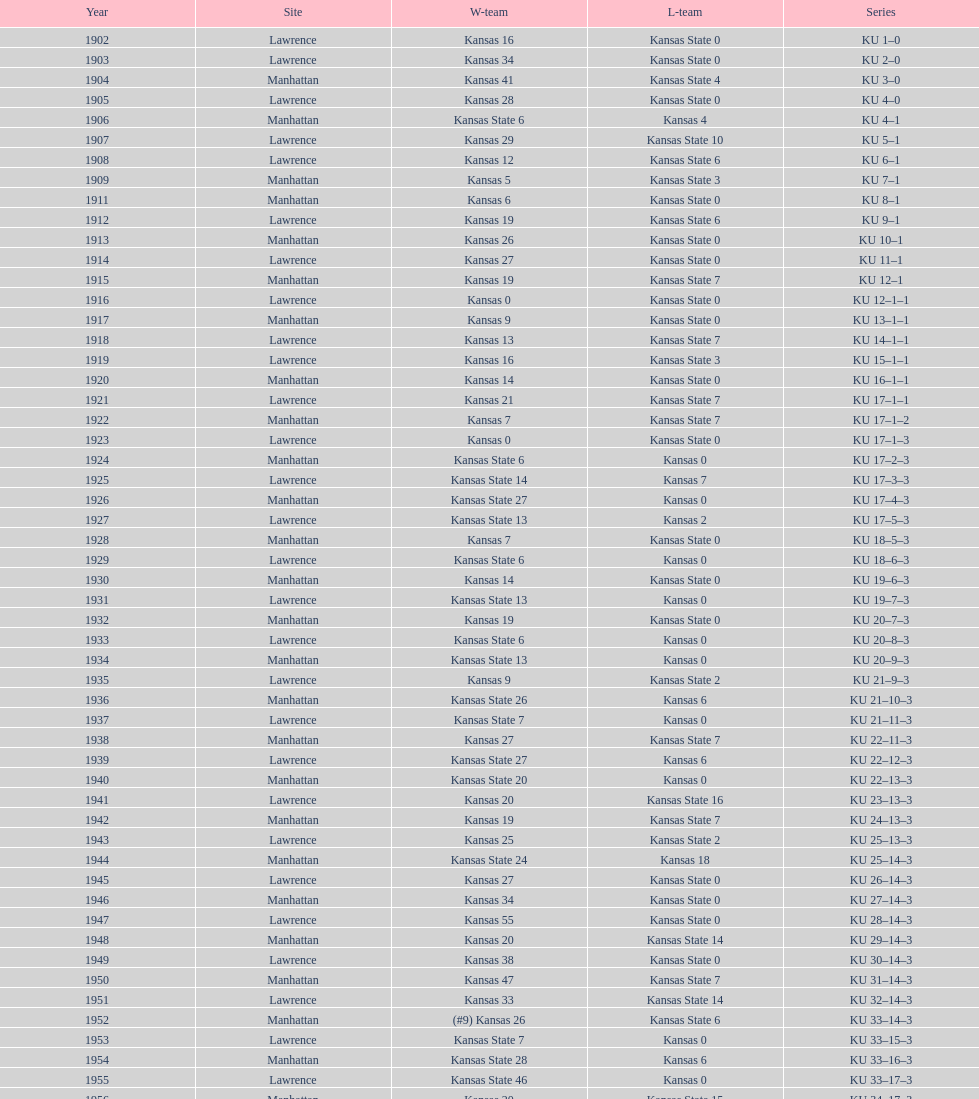Who had the most wins in the 1950's: kansas or kansas state? Kansas. 